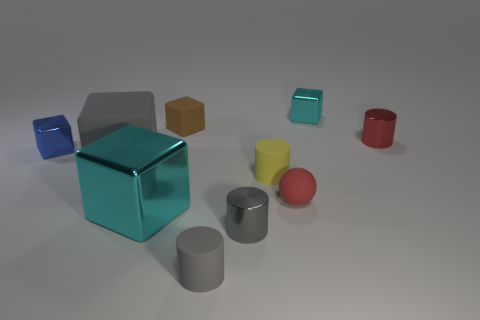Subtract all big cubes. How many cubes are left? 3 Subtract all spheres. How many objects are left? 9 Subtract all gray cylinders. How many cylinders are left? 2 Subtract 2 cylinders. How many cylinders are left? 2 Subtract all red cylinders. Subtract all red balls. How many cylinders are left? 3 Subtract all brown cubes. How many gray cylinders are left? 2 Subtract all blue blocks. Subtract all red matte balls. How many objects are left? 8 Add 8 large metallic things. How many large metallic things are left? 9 Add 6 small balls. How many small balls exist? 7 Subtract 0 brown spheres. How many objects are left? 10 